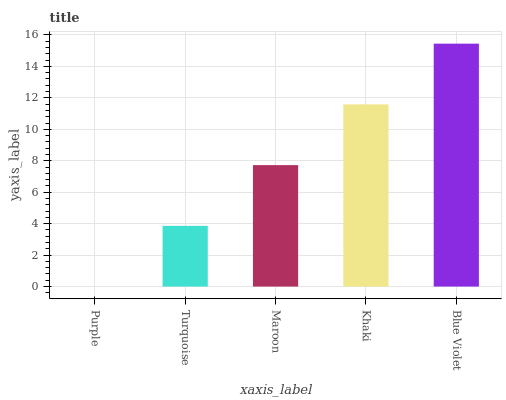Is Purple the minimum?
Answer yes or no. Yes. Is Blue Violet the maximum?
Answer yes or no. Yes. Is Turquoise the minimum?
Answer yes or no. No. Is Turquoise the maximum?
Answer yes or no. No. Is Turquoise greater than Purple?
Answer yes or no. Yes. Is Purple less than Turquoise?
Answer yes or no. Yes. Is Purple greater than Turquoise?
Answer yes or no. No. Is Turquoise less than Purple?
Answer yes or no. No. Is Maroon the high median?
Answer yes or no. Yes. Is Maroon the low median?
Answer yes or no. Yes. Is Khaki the high median?
Answer yes or no. No. Is Purple the low median?
Answer yes or no. No. 